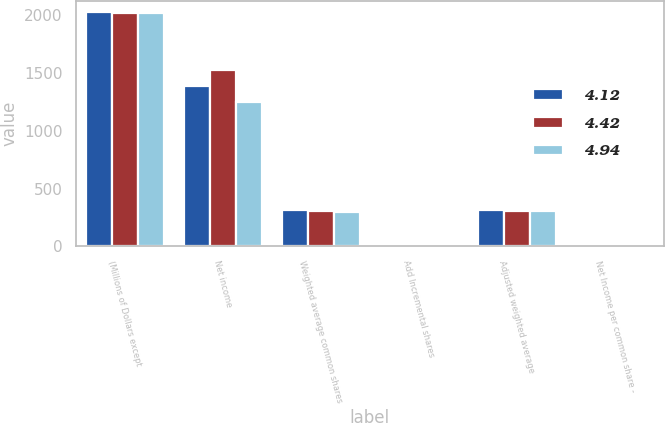Convert chart to OTSL. <chart><loc_0><loc_0><loc_500><loc_500><stacked_bar_chart><ecel><fcel>(Millions of Dollars except<fcel>Net income<fcel>Weighted average common shares<fcel>Add Incremental shares<fcel>Adjusted weighted average<fcel>Net Income per common share -<nl><fcel>4.12<fcel>2018<fcel>1382<fcel>311.7<fcel>1.2<fcel>312.9<fcel>4.42<nl><fcel>4.42<fcel>2017<fcel>1525<fcel>307.1<fcel>1.7<fcel>308.8<fcel>4.94<nl><fcel>4.94<fcel>2016<fcel>1245<fcel>300.4<fcel>1.5<fcel>301.9<fcel>4.12<nl></chart> 